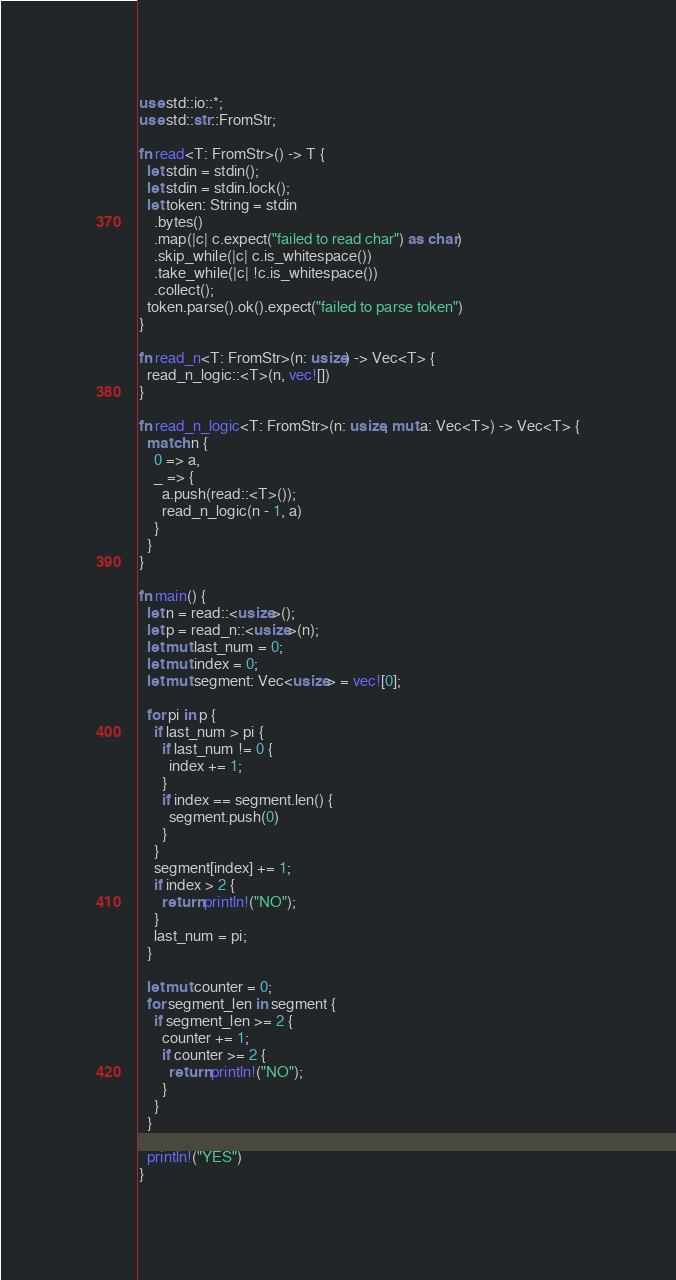Convert code to text. <code><loc_0><loc_0><loc_500><loc_500><_Rust_>use std::io::*;
use std::str::FromStr;

fn read<T: FromStr>() -> T {
  let stdin = stdin();
  let stdin = stdin.lock();
  let token: String = stdin
    .bytes()
    .map(|c| c.expect("failed to read char") as char)
    .skip_while(|c| c.is_whitespace())
    .take_while(|c| !c.is_whitespace())
    .collect();
  token.parse().ok().expect("failed to parse token")
}

fn read_n<T: FromStr>(n: usize) -> Vec<T> {
  read_n_logic::<T>(n, vec![])
}

fn read_n_logic<T: FromStr>(n: usize, mut a: Vec<T>) -> Vec<T> {
  match n {
    0 => a,
    _ => {
      a.push(read::<T>());
      read_n_logic(n - 1, a)
    }
  }
}

fn main() {
  let n = read::<usize>();
  let p = read_n::<usize>(n);
  let mut last_num = 0;
  let mut index = 0;
  let mut segment: Vec<usize> = vec![0];

  for pi in p {
    if last_num > pi {
      if last_num != 0 {
        index += 1;
      }
      if index == segment.len() {
        segment.push(0)
      }
    }
    segment[index] += 1;
    if index > 2 {
      return println!("NO");
    }
    last_num = pi;
  }

  let mut counter = 0;
  for segment_len in segment {
    if segment_len >= 2 {
      counter += 1;
      if counter >= 2 {
        return println!("NO");
      }
    }
  }

  println!("YES")
}
</code> 